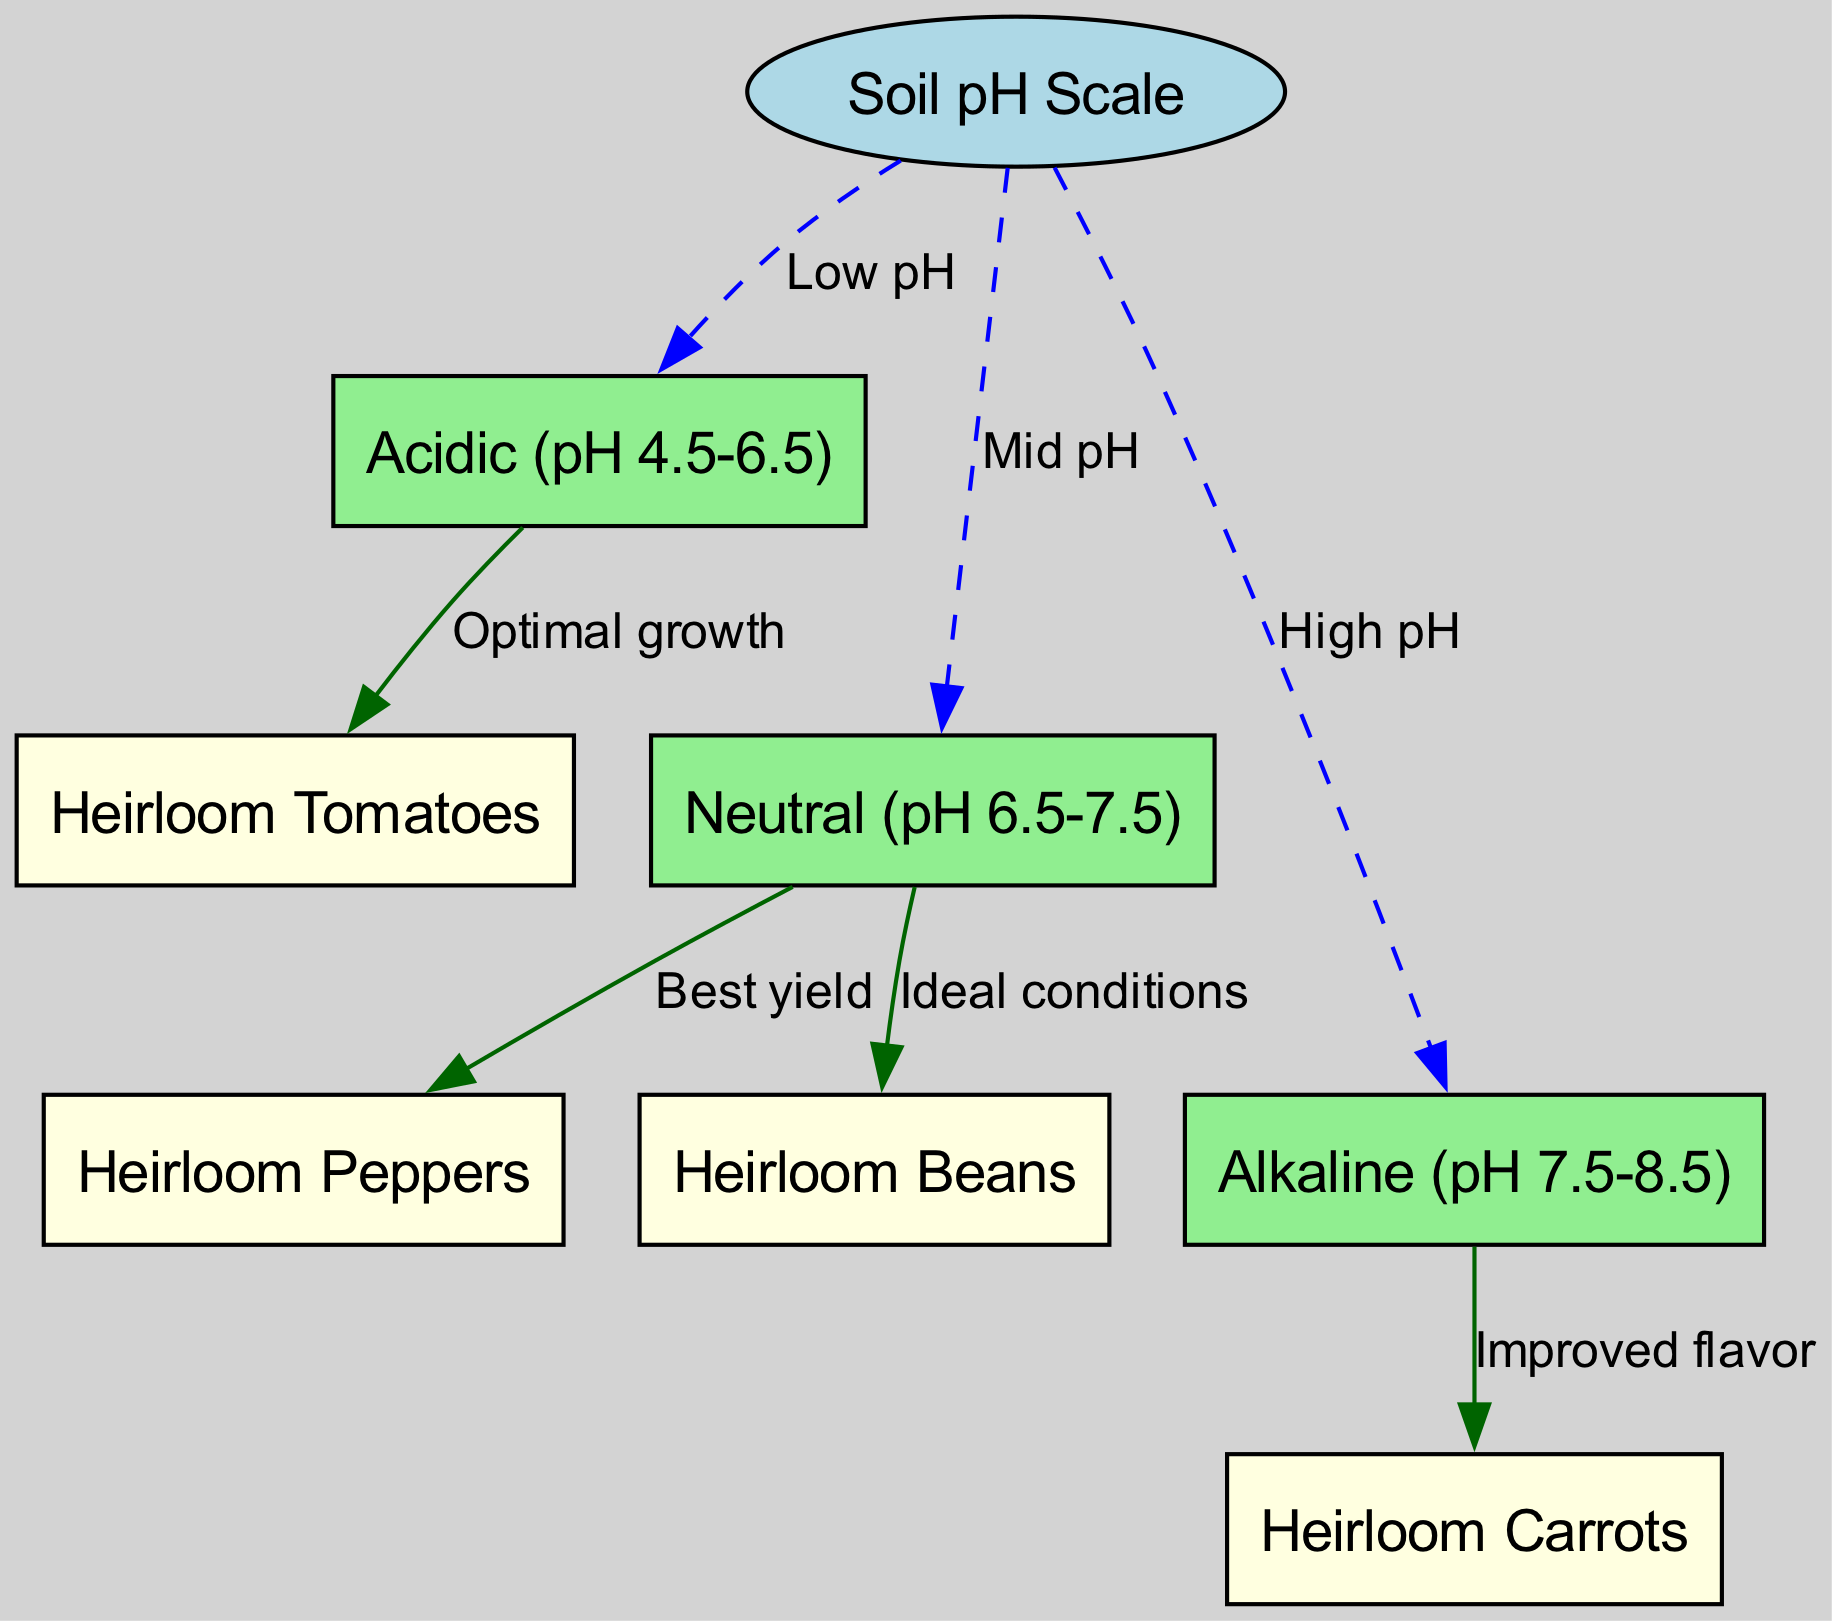What is the range of soil pH categorized as "Acidic"? The diagram defines "Acidic" as a range from 4.5 to 6.5 on the pH scale. This information is directly indicated under the node labeled "Acidic."
Answer: pH 4.5-6.5 Which heirloom vegetable variety is associated with "Neutral" pH for the best yield? The diagram links "Neutral" soil pH (6.5-7.5) to "Heirloom Peppers," showing that this vegetable performs optimally under those conditions.
Answer: Heirloom Peppers How many heirloom vegetable varieties are mentioned in the diagram? Counting the nodes labeled for heirloom vegetables—"Heirloom Tomatoes," "Heirloom Peppers," "Heirloom Carrots," and "Heirloom Beans"—there are four distinct varieties indicated in the diagram.
Answer: 4 What is the effect of "Alkaline" soil conditions on heirloom carrots? The diagram indicates that "Alkaline" conditions (pH 7.5-8.5) lead to "Improved flavor" of heirloom carrots, which is a direct relationship shown between the nodes.
Answer: Improved flavor Which heirloom vegetable is preferred for "Optimal growth" in "Acidic" soil? The node labeled "Optimal growth" leads to "Heirloom Tomatoes,” establishing that this variety thrives best in acidic conditions according to the diagram.
Answer: Heirloom Tomatoes Which type of soil pH leads to "Ideal conditions" for heirloom beans? The connection from the "Neutral" pH node (6.5-7.5) to "Heirloom Beans" suggests that this pH range supports ideal growth for this variety.
Answer: Neutral (pH 6.5-7.5) What type of diagram representation is used for the relationship between soil pH and heirloom vegetables? The relationships depicted show directional edges linking nodes, which is indicative of a directed graph or flow diagram format that represents the interactions between soil pH levels and vegetable varieties.
Answer: Directed graph What visual representation indicates low pH on the diagram? The "Low pH" label is specifically connected to the "Acidic" node, which shows that acidic conditions represent low pH and is visually depicted with a dashed edge in the graph.
Answer: Acidic 